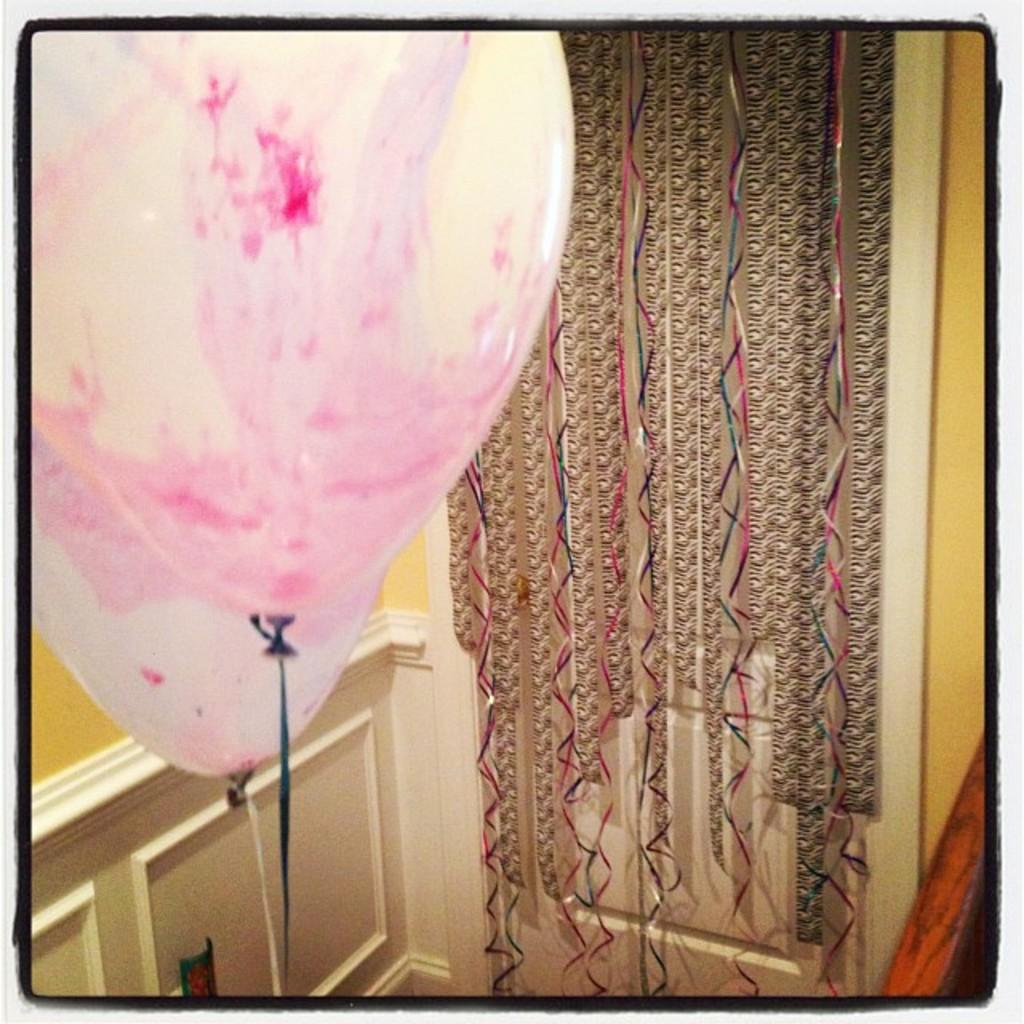What type of objects can be seen floating in the image? There are balloons in the image. What other items are present in the image that contribute to its overall appearance? There are decorative items in the image. What type of humor is being displayed by the locket in the image? There is no locket present in the image, so it is not possible to determine what type of humor it might display. 